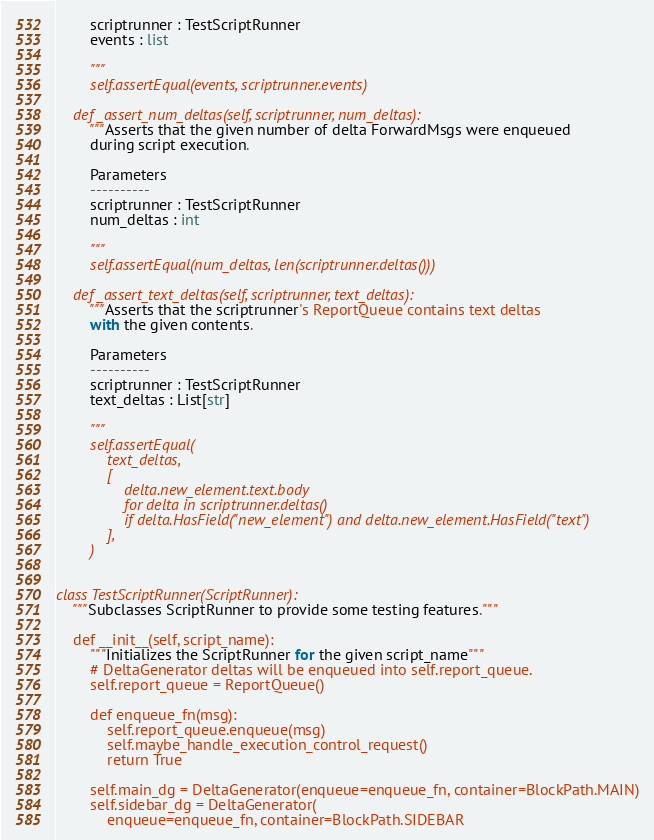<code> <loc_0><loc_0><loc_500><loc_500><_Python_>        scriptrunner : TestScriptRunner
        events : list

        """
        self.assertEqual(events, scriptrunner.events)

    def _assert_num_deltas(self, scriptrunner, num_deltas):
        """Asserts that the given number of delta ForwardMsgs were enqueued
        during script execution.

        Parameters
        ----------
        scriptrunner : TestScriptRunner
        num_deltas : int

        """
        self.assertEqual(num_deltas, len(scriptrunner.deltas()))

    def _assert_text_deltas(self, scriptrunner, text_deltas):
        """Asserts that the scriptrunner's ReportQueue contains text deltas
        with the given contents.

        Parameters
        ----------
        scriptrunner : TestScriptRunner
        text_deltas : List[str]

        """
        self.assertEqual(
            text_deltas,
            [
                delta.new_element.text.body
                for delta in scriptrunner.deltas()
                if delta.HasField("new_element") and delta.new_element.HasField("text")
            ],
        )


class TestScriptRunner(ScriptRunner):
    """Subclasses ScriptRunner to provide some testing features."""

    def __init__(self, script_name):
        """Initializes the ScriptRunner for the given script_name"""
        # DeltaGenerator deltas will be enqueued into self.report_queue.
        self.report_queue = ReportQueue()

        def enqueue_fn(msg):
            self.report_queue.enqueue(msg)
            self.maybe_handle_execution_control_request()
            return True

        self.main_dg = DeltaGenerator(enqueue=enqueue_fn, container=BlockPath.MAIN)
        self.sidebar_dg = DeltaGenerator(
            enqueue=enqueue_fn, container=BlockPath.SIDEBAR</code> 